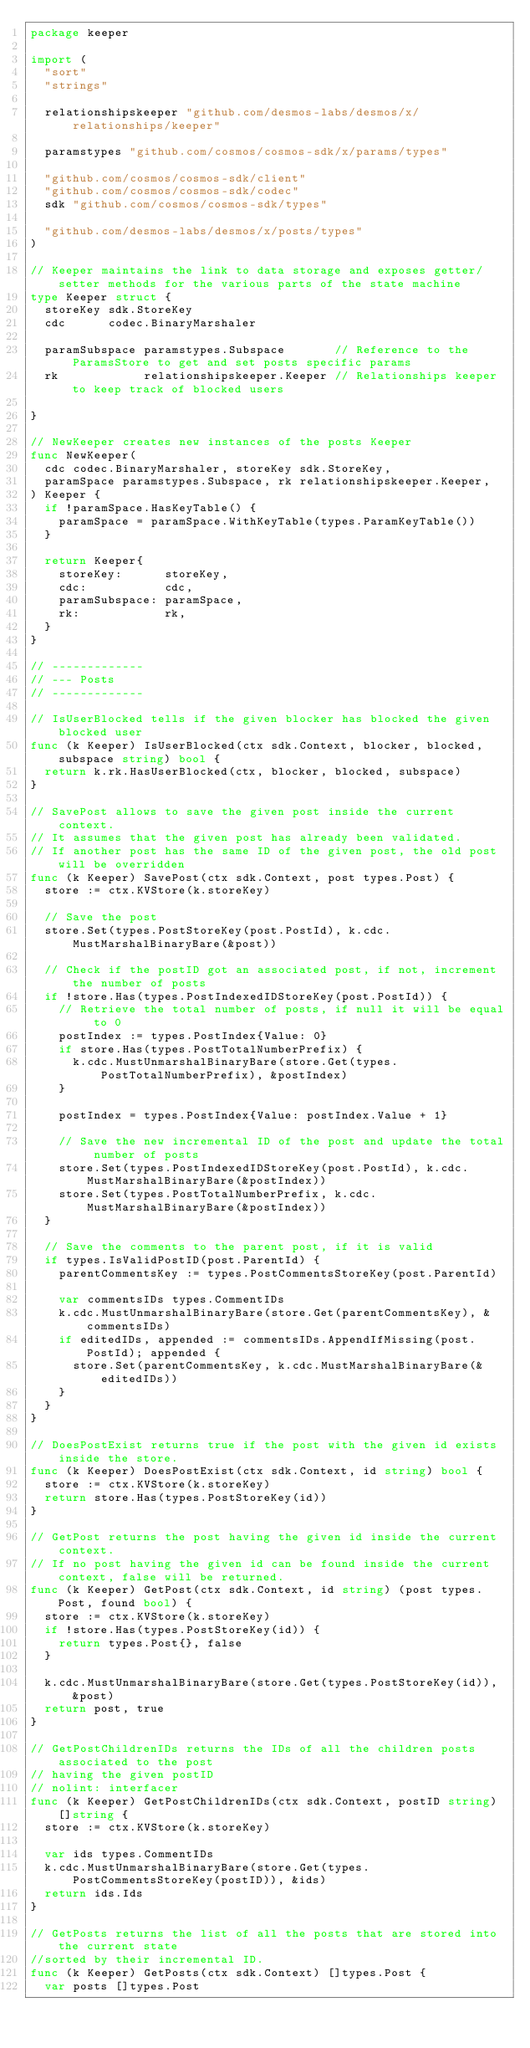Convert code to text. <code><loc_0><loc_0><loc_500><loc_500><_Go_>package keeper

import (
	"sort"
	"strings"

	relationshipskeeper "github.com/desmos-labs/desmos/x/relationships/keeper"

	paramstypes "github.com/cosmos/cosmos-sdk/x/params/types"

	"github.com/cosmos/cosmos-sdk/client"
	"github.com/cosmos/cosmos-sdk/codec"
	sdk "github.com/cosmos/cosmos-sdk/types"

	"github.com/desmos-labs/desmos/x/posts/types"
)

// Keeper maintains the link to data storage and exposes getter/setter methods for the various parts of the state machine
type Keeper struct {
	storeKey sdk.StoreKey
	cdc      codec.BinaryMarshaler

	paramSubspace paramstypes.Subspace       // Reference to the ParamsStore to get and set posts specific params
	rk            relationshipskeeper.Keeper // Relationships keeper to keep track of blocked users

}

// NewKeeper creates new instances of the posts Keeper
func NewKeeper(
	cdc codec.BinaryMarshaler, storeKey sdk.StoreKey,
	paramSpace paramstypes.Subspace, rk relationshipskeeper.Keeper,
) Keeper {
	if !paramSpace.HasKeyTable() {
		paramSpace = paramSpace.WithKeyTable(types.ParamKeyTable())
	}

	return Keeper{
		storeKey:      storeKey,
		cdc:           cdc,
		paramSubspace: paramSpace,
		rk:            rk,
	}
}

// -------------
// --- Posts
// -------------

// IsUserBlocked tells if the given blocker has blocked the given blocked user
func (k Keeper) IsUserBlocked(ctx sdk.Context, blocker, blocked, subspace string) bool {
	return k.rk.HasUserBlocked(ctx, blocker, blocked, subspace)
}

// SavePost allows to save the given post inside the current context.
// It assumes that the given post has already been validated.
// If another post has the same ID of the given post, the old post will be overridden
func (k Keeper) SavePost(ctx sdk.Context, post types.Post) {
	store := ctx.KVStore(k.storeKey)

	// Save the post
	store.Set(types.PostStoreKey(post.PostId), k.cdc.MustMarshalBinaryBare(&post))

	// Check if the postID got an associated post, if not, increment the number of posts
	if !store.Has(types.PostIndexedIDStoreKey(post.PostId)) {
		// Retrieve the total number of posts, if null it will be equal to 0
		postIndex := types.PostIndex{Value: 0}
		if store.Has(types.PostTotalNumberPrefix) {
			k.cdc.MustUnmarshalBinaryBare(store.Get(types.PostTotalNumberPrefix), &postIndex)
		}

		postIndex = types.PostIndex{Value: postIndex.Value + 1}

		// Save the new incremental ID of the post and update the total number of posts
		store.Set(types.PostIndexedIDStoreKey(post.PostId), k.cdc.MustMarshalBinaryBare(&postIndex))
		store.Set(types.PostTotalNumberPrefix, k.cdc.MustMarshalBinaryBare(&postIndex))
	}

	// Save the comments to the parent post, if it is valid
	if types.IsValidPostID(post.ParentId) {
		parentCommentsKey := types.PostCommentsStoreKey(post.ParentId)

		var commentsIDs types.CommentIDs
		k.cdc.MustUnmarshalBinaryBare(store.Get(parentCommentsKey), &commentsIDs)
		if editedIDs, appended := commentsIDs.AppendIfMissing(post.PostId); appended {
			store.Set(parentCommentsKey, k.cdc.MustMarshalBinaryBare(&editedIDs))
		}
	}
}

// DoesPostExist returns true if the post with the given id exists inside the store.
func (k Keeper) DoesPostExist(ctx sdk.Context, id string) bool {
	store := ctx.KVStore(k.storeKey)
	return store.Has(types.PostStoreKey(id))
}

// GetPost returns the post having the given id inside the current context.
// If no post having the given id can be found inside the current context, false will be returned.
func (k Keeper) GetPost(ctx sdk.Context, id string) (post types.Post, found bool) {
	store := ctx.KVStore(k.storeKey)
	if !store.Has(types.PostStoreKey(id)) {
		return types.Post{}, false
	}

	k.cdc.MustUnmarshalBinaryBare(store.Get(types.PostStoreKey(id)), &post)
	return post, true
}

// GetPostChildrenIDs returns the IDs of all the children posts associated to the post
// having the given postID
// nolint: interfacer
func (k Keeper) GetPostChildrenIDs(ctx sdk.Context, postID string) []string {
	store := ctx.KVStore(k.storeKey)

	var ids types.CommentIDs
	k.cdc.MustUnmarshalBinaryBare(store.Get(types.PostCommentsStoreKey(postID)), &ids)
	return ids.Ids
}

// GetPosts returns the list of all the posts that are stored into the current state
//sorted by their incremental ID.
func (k Keeper) GetPosts(ctx sdk.Context) []types.Post {
	var posts []types.Post</code> 